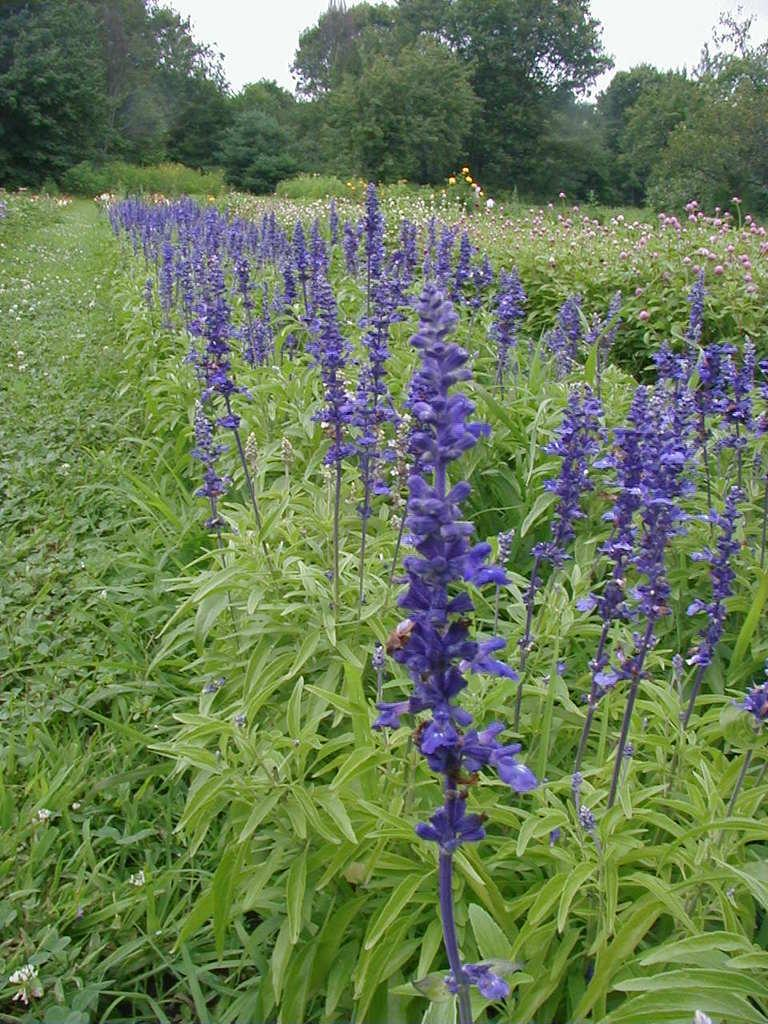What type of plants can be seen in the image? There are plants with flowers in the image. What can be seen in the background of the image? There are trees in the background of the image. How many sisters are present in the image? There are no sisters mentioned or depicted in the image. What type of attraction can be seen in the image? There is no attraction present in the image; it features plants with flowers and trees in the background. 